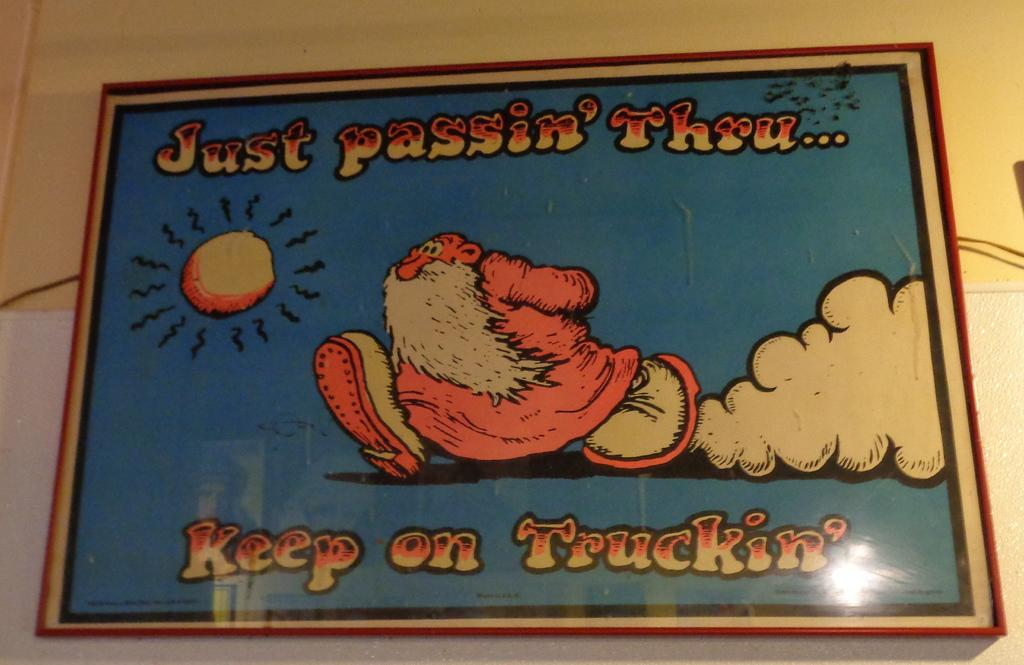<image>
Summarize the visual content of the image. a poster that has a man on it with the wording just keep trucking thru 